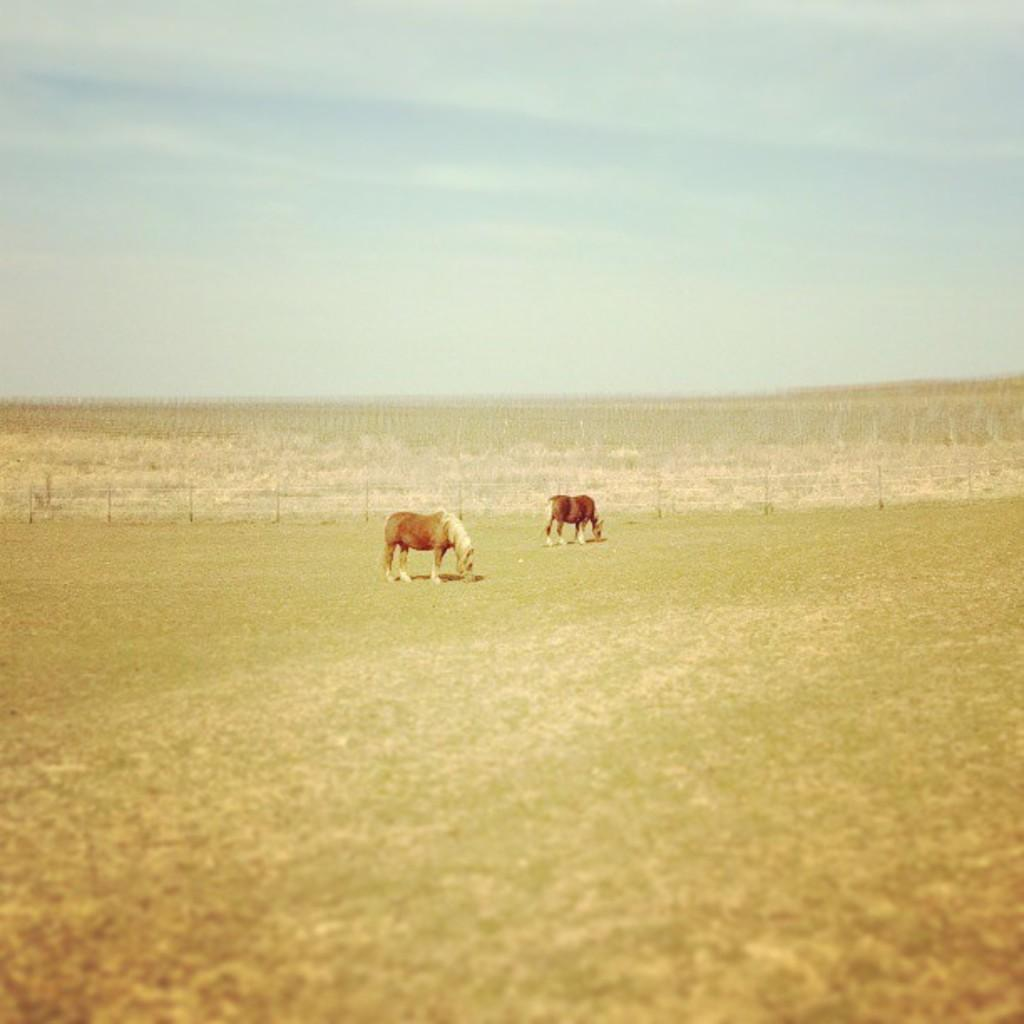How many animals can be seen in the image? There are two animals in the image. What are the animals doing in the image? The animals are grazing the grass. What can be seen in the background of the image? There is a fence and fields visible in the background of the image. What is the condition of the sky in the image? The sky is clear in the image. What type of vessel can be seen sailing in the downtown area in the image? There is no vessel or downtown area present in the image; it features two animals grazing in a field with a clear sky. 